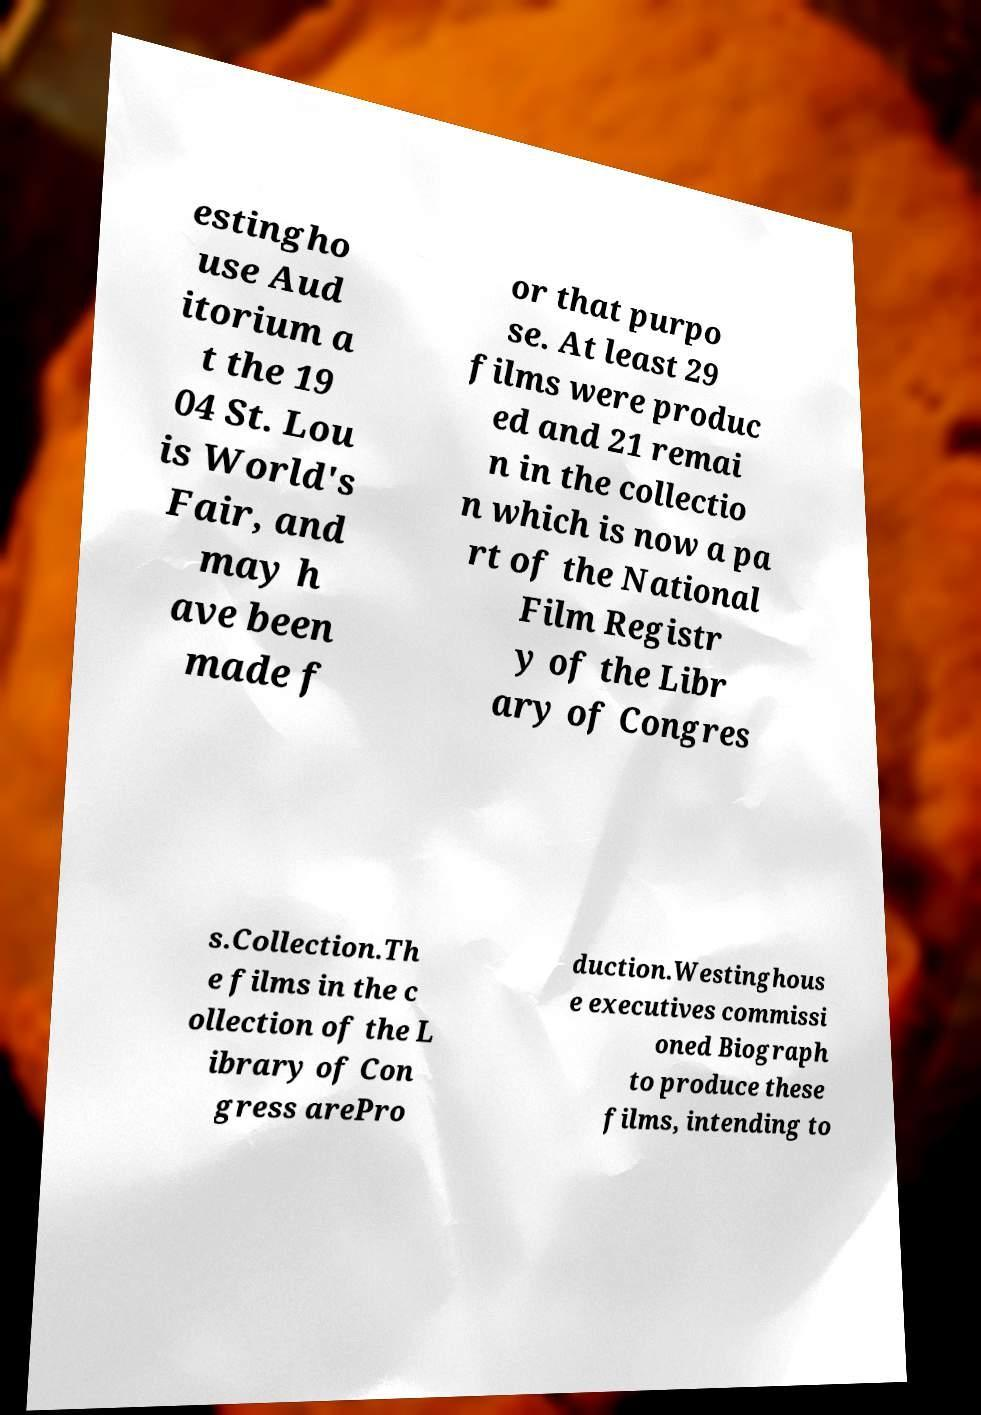Please identify and transcribe the text found in this image. estingho use Aud itorium a t the 19 04 St. Lou is World's Fair, and may h ave been made f or that purpo se. At least 29 films were produc ed and 21 remai n in the collectio n which is now a pa rt of the National Film Registr y of the Libr ary of Congres s.Collection.Th e films in the c ollection of the L ibrary of Con gress arePro duction.Westinghous e executives commissi oned Biograph to produce these films, intending to 